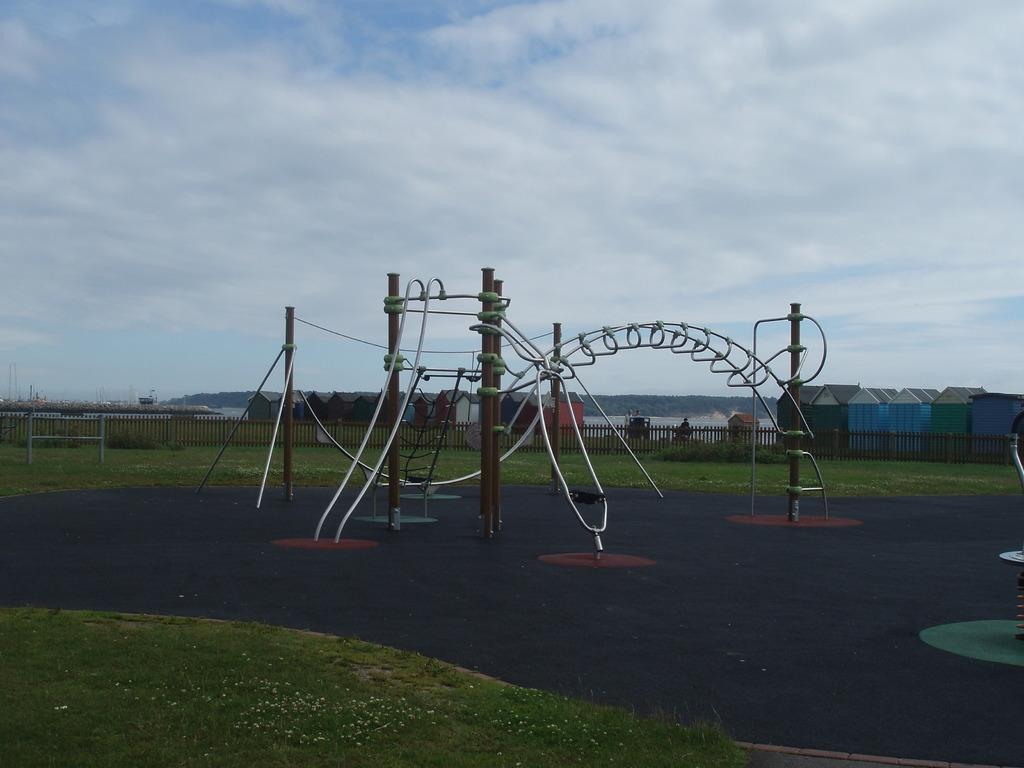What type of structures can be seen in the image? There are houses and a structure made up of poles and metal pipes in the image. What type of natural elements are present in the image? There is grass, plants, water, and hills visible in the image. What type of barrier can be seen in the image? There is a fence in the image. What is visible in the background of the image? The sky is visible in the background of the image. What type of horse can be seen playing a joke on someone's mind in the image? There is no horse or reference to a mind or joke in the image; it features houses, a fence, grass, plants, water, hills, a structure made up of poles and metal pipes, and the sky. 